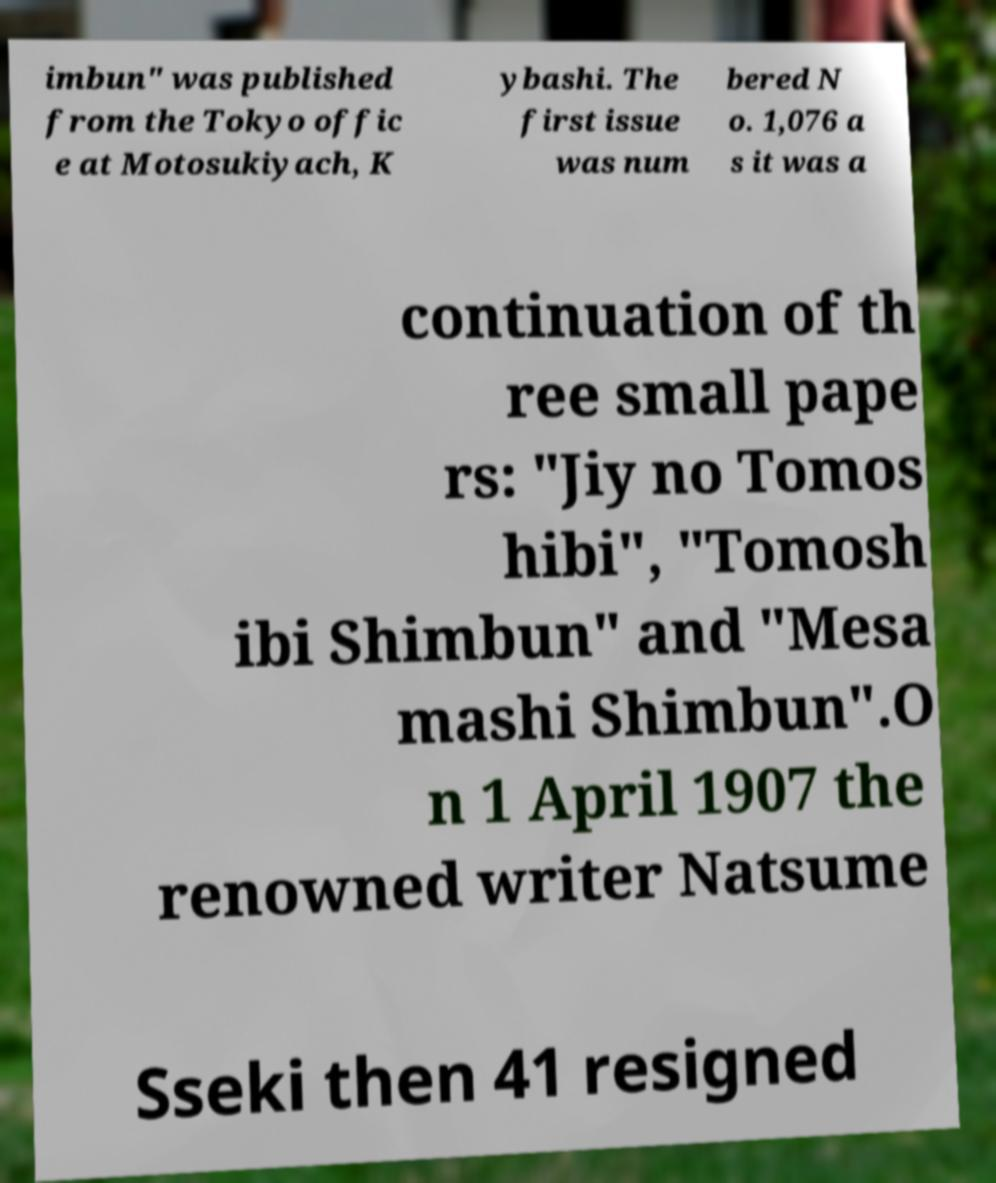What messages or text are displayed in this image? I need them in a readable, typed format. imbun" was published from the Tokyo offic e at Motosukiyach, K ybashi. The first issue was num bered N o. 1,076 a s it was a continuation of th ree small pape rs: "Jiy no Tomos hibi", "Tomosh ibi Shimbun" and "Mesa mashi Shimbun".O n 1 April 1907 the renowned writer Natsume Sseki then 41 resigned 